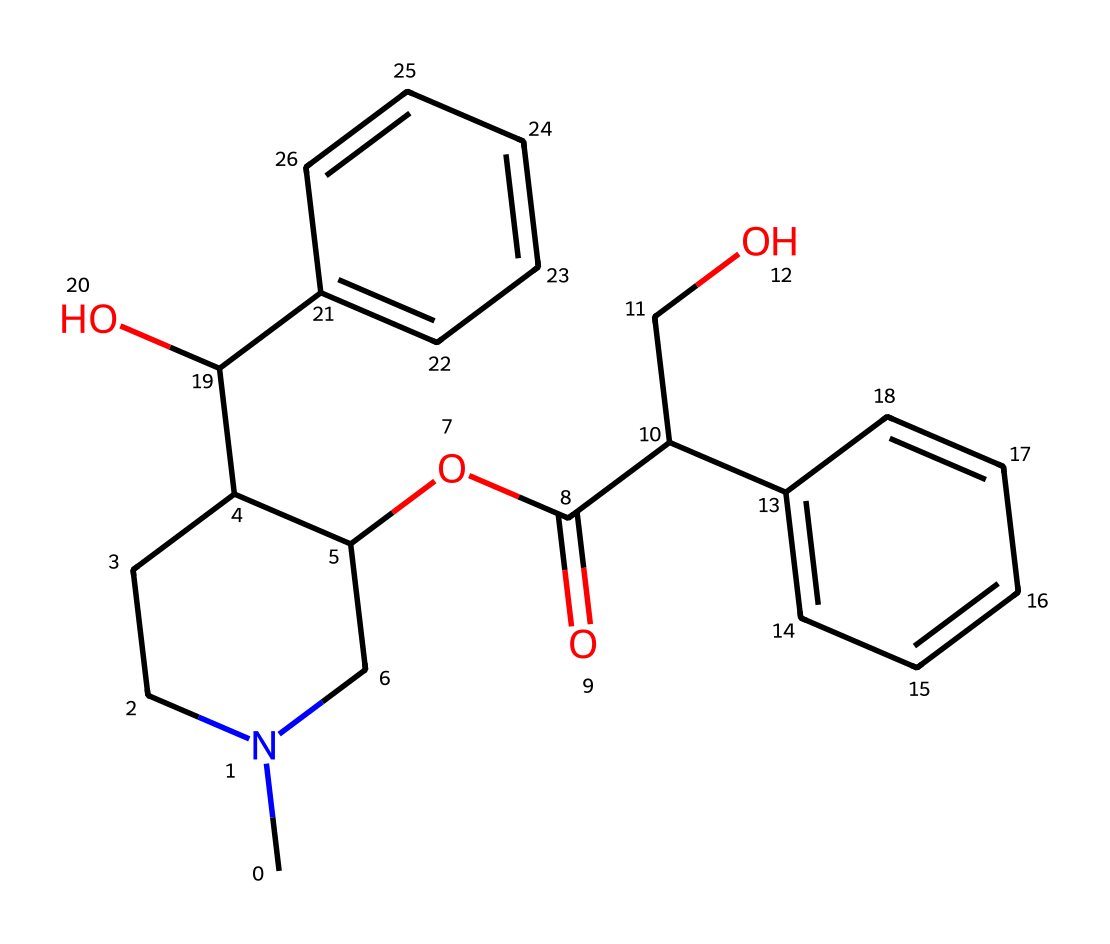how many carbon atoms are in the structure? By examining the SMILES representation, I can count the carbon (C) atoms present. Each "C" stands for a carbon atom, and I tally them up in the entire structure, resulting in a total count.
Answer: 21 what functional groups are present in this compound? I look for recognizable patterns in the SMILES. The "OC(=O)" indicates a carboxylate, and "C(O)" shows the presence of a hydroxyl group. Therefore, I identify both a carboxylic acid and an alcohol functional group in the structure.
Answer: carboxylate, alcohol what is the molecular weight of atropine based on its chemical structure? To ascertain the molecular weight, I compute the contributions from each atom type in the structure. Carbon (C) = 12.01 g/mol, Oxygen (O) = 16.00 g/mol, Nitrogen (N) = 14.01 g/mol, and Hydrogen (H) = 1.01 g/mol. Adding the weights based on the number of each type of atom gives the total molecular weight.
Answer: 303.37 g/mol does the compound contain a nitrogen atom? By checking the SMILES representation, I look for any occurrences of "N," which indicates the presence of a nitrogen atom in the structure. As there is indeed an "N" present, I confirm its existence.
Answer: yes what type of isomers does the atropine structure exhibit? To determine isomer types, I assess the arrangement of atoms and any double bonds in the structure. Atropine can exhibit structural isomerism due to different connectivity and stereoisomerism due to different spatial orientation of the nitrogen-containing part.
Answer: structural and stereoisomers what role does the hydroxyl group play in the properties of atropine? The hydroxyl group (–OH) typically influences the solubility and reactivity of compounds. In atropine, it increases solubility in water and impacts its pharmacological activity, particularly in relation to eye drop formulary.
Answer: increases solubility and reactivity 